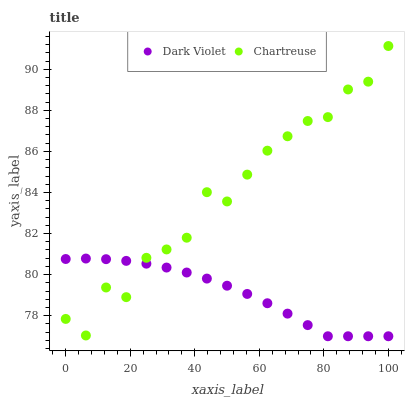Does Dark Violet have the minimum area under the curve?
Answer yes or no. Yes. Does Chartreuse have the maximum area under the curve?
Answer yes or no. Yes. Does Dark Violet have the maximum area under the curve?
Answer yes or no. No. Is Dark Violet the smoothest?
Answer yes or no. Yes. Is Chartreuse the roughest?
Answer yes or no. Yes. Is Dark Violet the roughest?
Answer yes or no. No. Does Dark Violet have the lowest value?
Answer yes or no. Yes. Does Chartreuse have the highest value?
Answer yes or no. Yes. Does Dark Violet have the highest value?
Answer yes or no. No. Does Dark Violet intersect Chartreuse?
Answer yes or no. Yes. Is Dark Violet less than Chartreuse?
Answer yes or no. No. Is Dark Violet greater than Chartreuse?
Answer yes or no. No. 